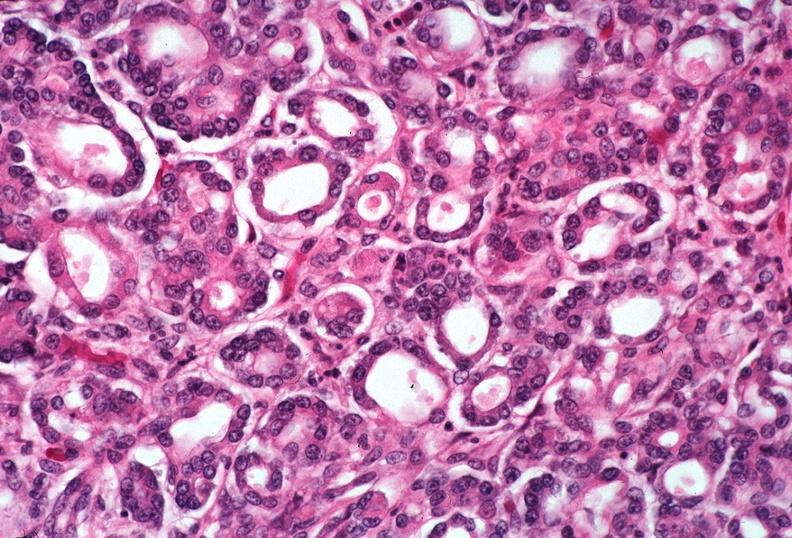does fracture show pancreas, uremic pancreatitis due to polycystic kidney?
Answer the question using a single word or phrase. No 